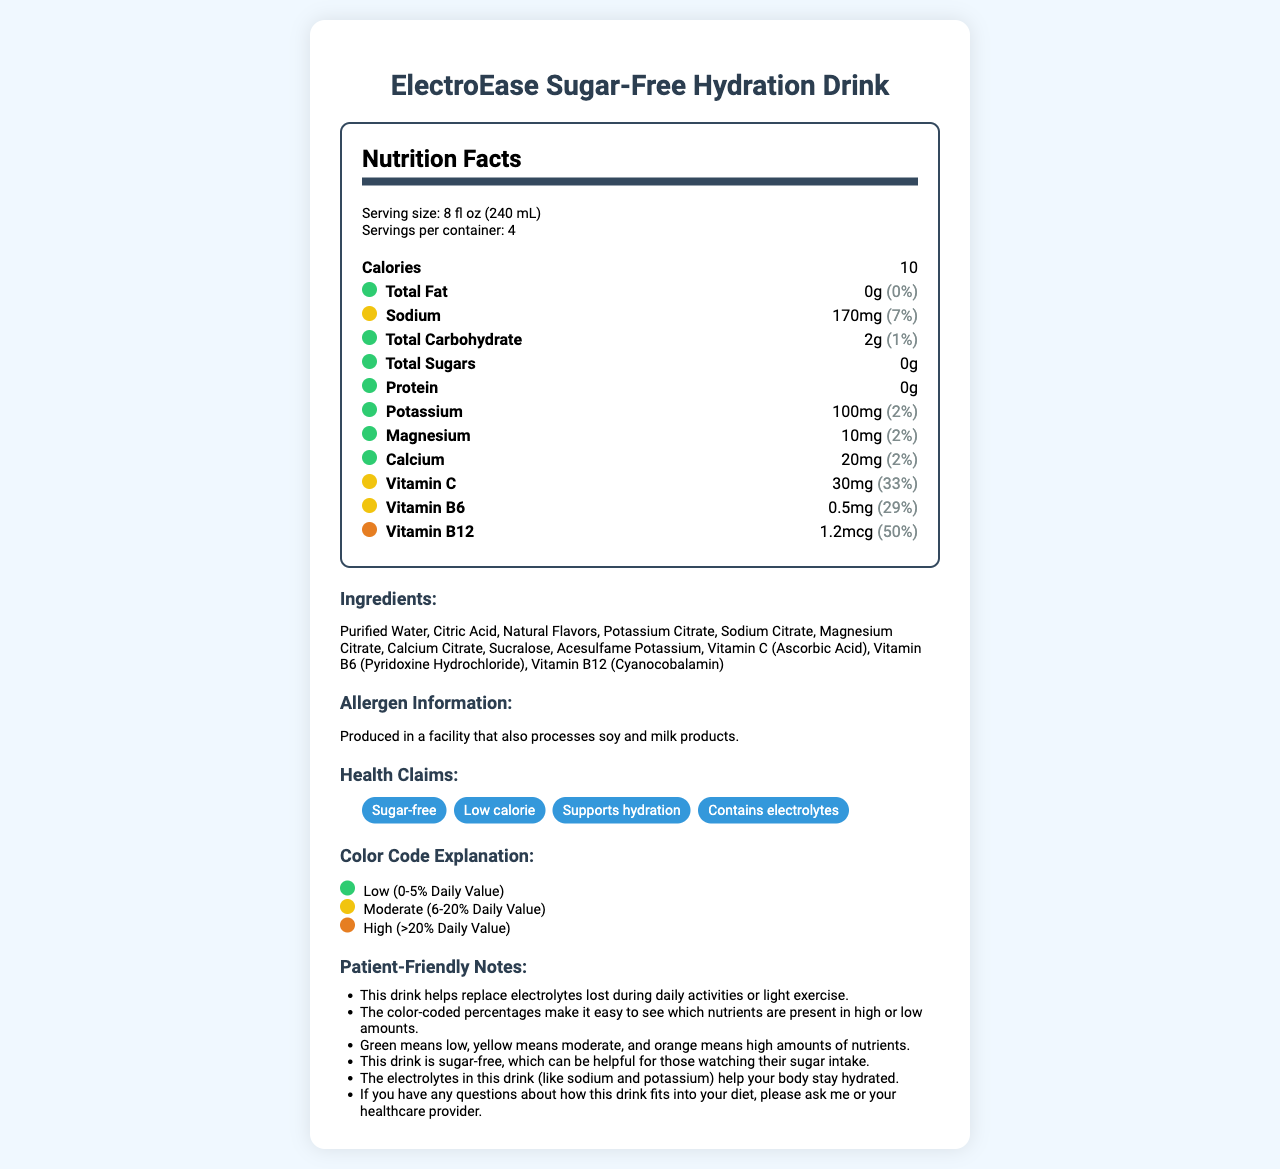what is the serving size? The serving size is listed under the "Serving size" section at the top of the document.
Answer: 8 fl oz (240 mL) how many servings are in one container? The number of servings per container is specified as 4 just below the serving size.
Answer: 4 how many calories are in one serving? The calorie count for one serving is displayed as 10 under the "Calories" section.
Answer: 10 what are the main ingredients of the drink? The ingredients are listed in the "Ingredients" section of the document.
Answer: Purified Water, Citric Acid, Natural Flavors, Potassium Citrate, Sodium Citrate, Magnesium Citrate, Calcium Citrate, Sucralose, Acesulfame Potassium, Vitamin C (Ascorbic Acid), Vitamin B6 (Pyridoxine Hydrochloride), Vitamin B12 (Cyanocobalamin) what does the color green signify in the nutrient color codes? The color code explanation section states that green indicates a low daily value percentage, which is 0-5%.
Answer: Low (0-5% Daily Value) which nutrient has the highest daily value percentage? The Vitamin B12 shows a daily value percentage of 50%, which is the highest among the listed nutrients.
Answer: Vitamin B12 does the drink contain any sugar? The "Total Sugars" section shows 0g, indicating no sugar content.
Answer: No which vitamins are present in moderate amounts (6-20% daily value)? A. Vitamin C B. Vitamin B6 C. Vitamin B12 D. Both A and B According to the document, Vitamin C (33%) and Vitamin B6 (29%) fall in the moderate category.
Answer: D. Both A and B which nutrient is not listed in the document? A. Fat B. Sodium C. Iron D. Potassium The document does not mention Iron, but it lists Fat, Sodium, and Potassium.
Answer: C. Iron are any allergens present in the product? The allergen information states that it is produced in a facility that processes soy and milk products.
Answer: Yes is the drink suitable for someone who is watching their sugar intake? One of the patient-friendly notes mentions this drink is sugar-free, which is suitable for those watching their sugar intake.
Answer: Yes describe the main points of the document. The document aims to provide a detailed yet easily comprehensible overview of the product's nutritional facts, ingredients, and other related claims.
Answer: The document provides nutritional information for ElectroEase Sugar-Free Hydration Drink. It lists details about serving size, calories, and various nutrients with color-coded daily value percentages. The document also includes ingredients, allergen information, health claims, and patient-friendly notes. The color codes help in quickly understanding the nutrient levels. what is the exact amount of calcium in one serving? The "Calcium" section shows that one serving contains 20mg of calcium.
Answer: 20mg is Vitamin A listed as a nutrient in this drink? Vitamin A is not mentioned in the list of nutrients.
Answer: No does the drink help with hydration? One of the health claims explicitly states that the drink supports hydration.
Answer: Yes what is the production facility's relation to soy and milk products? The allergen information indicates that the product is produced in a facility that processes soy and milk products.
Answer: Produced in a facility that also processes soy and milk products. what is the manufacturer's name? The document does not provide information about the manufacturer's name.
Answer: Not enough information 